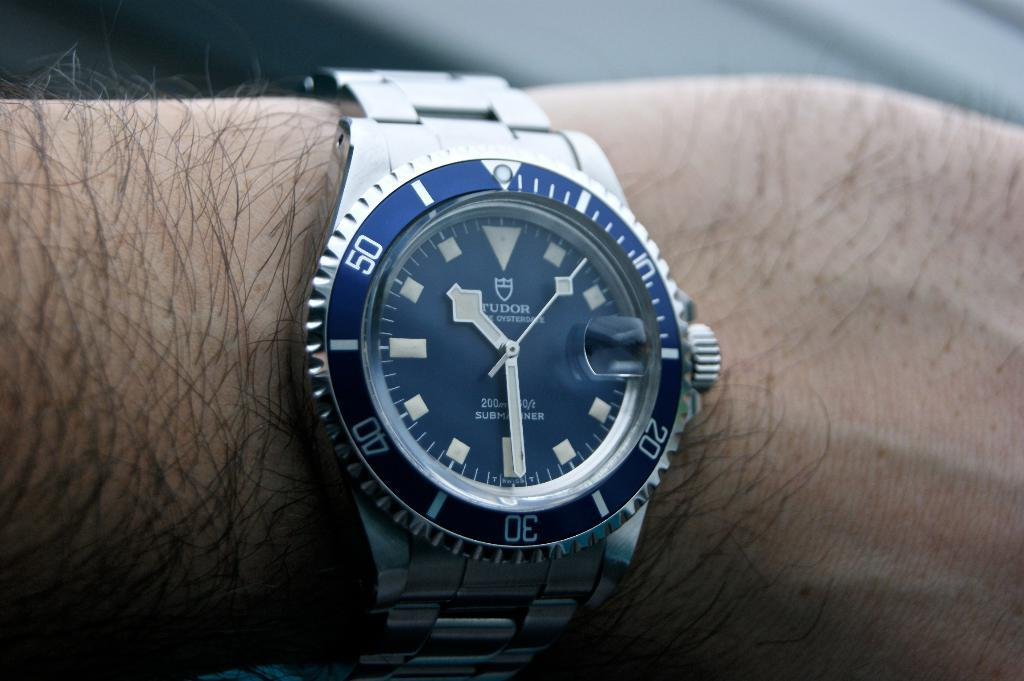Provide a one-sentence caption for the provided image. A person is wearing a Tudor wristwatch with a blue face indicating that the time is 10:30. 